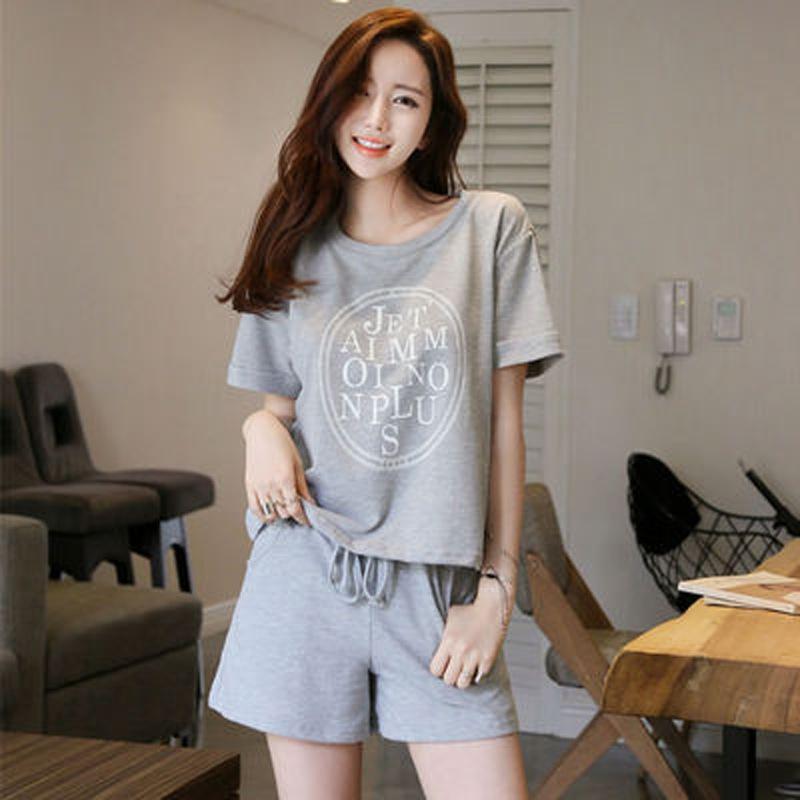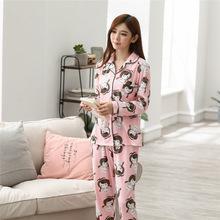The first image is the image on the left, the second image is the image on the right. Assess this claim about the two images: "One image shows a model in pink loungewear featuring a face on it.". Correct or not? Answer yes or no. Yes. The first image is the image on the left, the second image is the image on the right. Examine the images to the left and right. Is the description "The right image contains a lady wearing pajamas featuring a large teddy bear, not a frog, with a window and a couch in the background." accurate? Answer yes or no. No. 